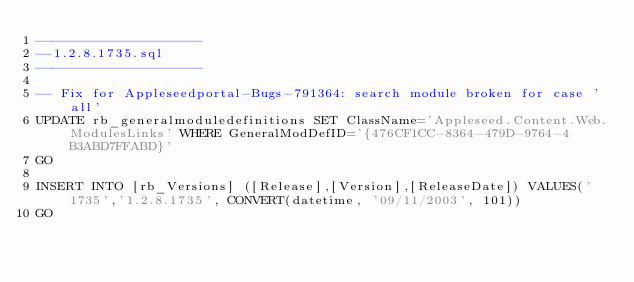Convert code to text. <code><loc_0><loc_0><loc_500><loc_500><_SQL_>---------------------
--1.2.8.1735.sql
---------------------

-- Fix for Appleseedportal-Bugs-791364: search module broken for case 'all'
UPDATE rb_generalmoduledefinitions SET ClassName='Appleseed.Content.Web.ModulesLinks' WHERE GeneralModDefID='{476CF1CC-8364-479D-9764-4B3ABD7FFABD}'
GO

INSERT INTO [rb_Versions] ([Release],[Version],[ReleaseDate]) VALUES('1735','1.2.8.1735', CONVERT(datetime, '09/11/2003', 101))
GO
</code> 